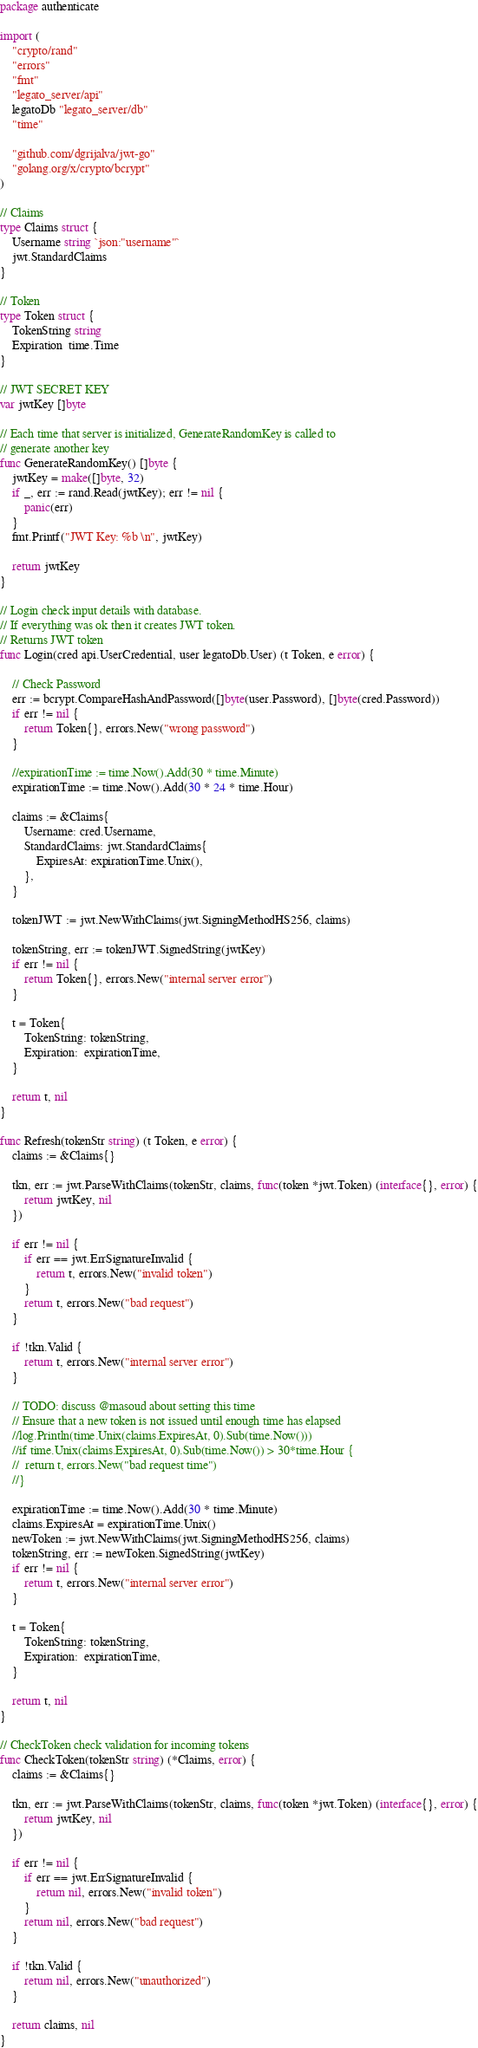Convert code to text. <code><loc_0><loc_0><loc_500><loc_500><_Go_>package authenticate

import (
	"crypto/rand"
	"errors"
	"fmt"
	"legato_server/api"
	legatoDb "legato_server/db"
	"time"

	"github.com/dgrijalva/jwt-go"
	"golang.org/x/crypto/bcrypt"
)

// Claims
type Claims struct {
	Username string `json:"username"`
	jwt.StandardClaims
}

// Token
type Token struct {
	TokenString string
	Expiration  time.Time
}

// JWT SECRET KEY
var jwtKey []byte

// Each time that server is initialized, GenerateRandomKey is called to
// generate another key
func GenerateRandomKey() []byte {
	jwtKey = make([]byte, 32)
	if _, err := rand.Read(jwtKey); err != nil {
		panic(err)
	}
	fmt.Printf("JWT Key: %b \n", jwtKey)

	return jwtKey
}

// Login check input details with database.
// If everything was ok then it creates JWT token.
// Returns JWT token
func Login(cred api.UserCredential, user legatoDb.User) (t Token, e error) {

	// Check Password
	err := bcrypt.CompareHashAndPassword([]byte(user.Password), []byte(cred.Password))
	if err != nil {
		return Token{}, errors.New("wrong password")
	}

	//expirationTime := time.Now().Add(30 * time.Minute)
	expirationTime := time.Now().Add(30 * 24 * time.Hour)

	claims := &Claims{
		Username: cred.Username,
		StandardClaims: jwt.StandardClaims{
			ExpiresAt: expirationTime.Unix(),
		},
	}

	tokenJWT := jwt.NewWithClaims(jwt.SigningMethodHS256, claims)

	tokenString, err := tokenJWT.SignedString(jwtKey)
	if err != nil {
		return Token{}, errors.New("internal server error")
	}

	t = Token{
		TokenString: tokenString,
		Expiration:  expirationTime,
	}

	return t, nil
}

func Refresh(tokenStr string) (t Token, e error) {
	claims := &Claims{}

	tkn, err := jwt.ParseWithClaims(tokenStr, claims, func(token *jwt.Token) (interface{}, error) {
		return jwtKey, nil
	})

	if err != nil {
		if err == jwt.ErrSignatureInvalid {
			return t, errors.New("invalid token")
		}
		return t, errors.New("bad request")
	}

	if !tkn.Valid {
		return t, errors.New("internal server error")
	}

	// TODO: discuss @masoud about setting this time
	// Ensure that a new token is not issued until enough time has elapsed
	//log.Println(time.Unix(claims.ExpiresAt, 0).Sub(time.Now()))
	//if time.Unix(claims.ExpiresAt, 0).Sub(time.Now()) > 30*time.Hour {
	//	return t, errors.New("bad request time")
	//}

	expirationTime := time.Now().Add(30 * time.Minute)
	claims.ExpiresAt = expirationTime.Unix()
	newToken := jwt.NewWithClaims(jwt.SigningMethodHS256, claims)
	tokenString, err := newToken.SignedString(jwtKey)
	if err != nil {
		return t, errors.New("internal server error")
	}

	t = Token{
		TokenString: tokenString,
		Expiration:  expirationTime,
	}

	return t, nil
}

// CheckToken check validation for incoming tokens
func CheckToken(tokenStr string) (*Claims, error) {
	claims := &Claims{}

	tkn, err := jwt.ParseWithClaims(tokenStr, claims, func(token *jwt.Token) (interface{}, error) {
		return jwtKey, nil
	})

	if err != nil {
		if err == jwt.ErrSignatureInvalid {
			return nil, errors.New("invalid token")
		}
		return nil, errors.New("bad request")
	}

	if !tkn.Valid {
		return nil, errors.New("unauthorized")
	}

	return claims, nil
}
</code> 